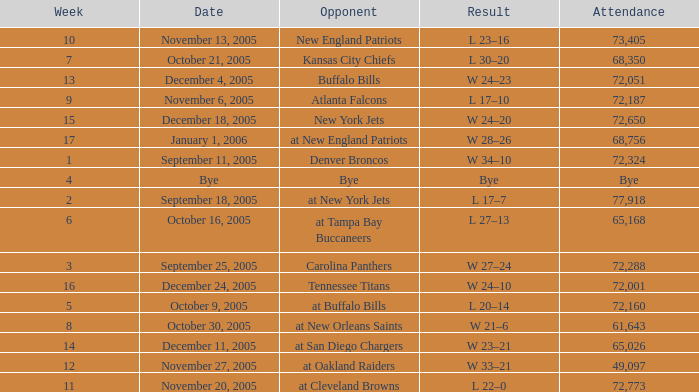On what Date was the Attendance 73,405? November 13, 2005. 